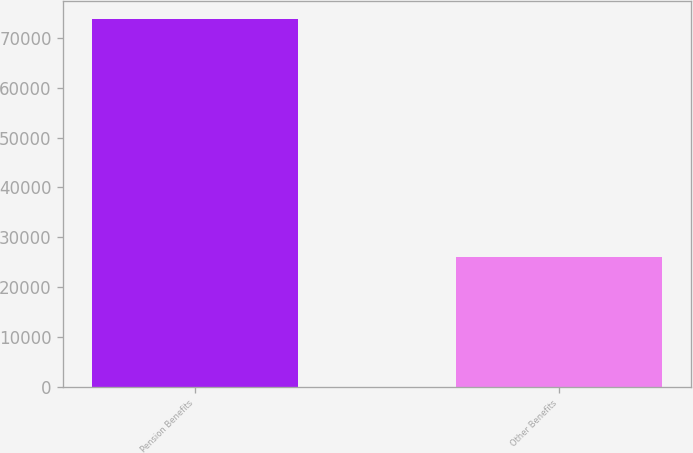<chart> <loc_0><loc_0><loc_500><loc_500><bar_chart><fcel>Pension Benefits<fcel>Other Benefits<nl><fcel>73684<fcel>26129<nl></chart> 